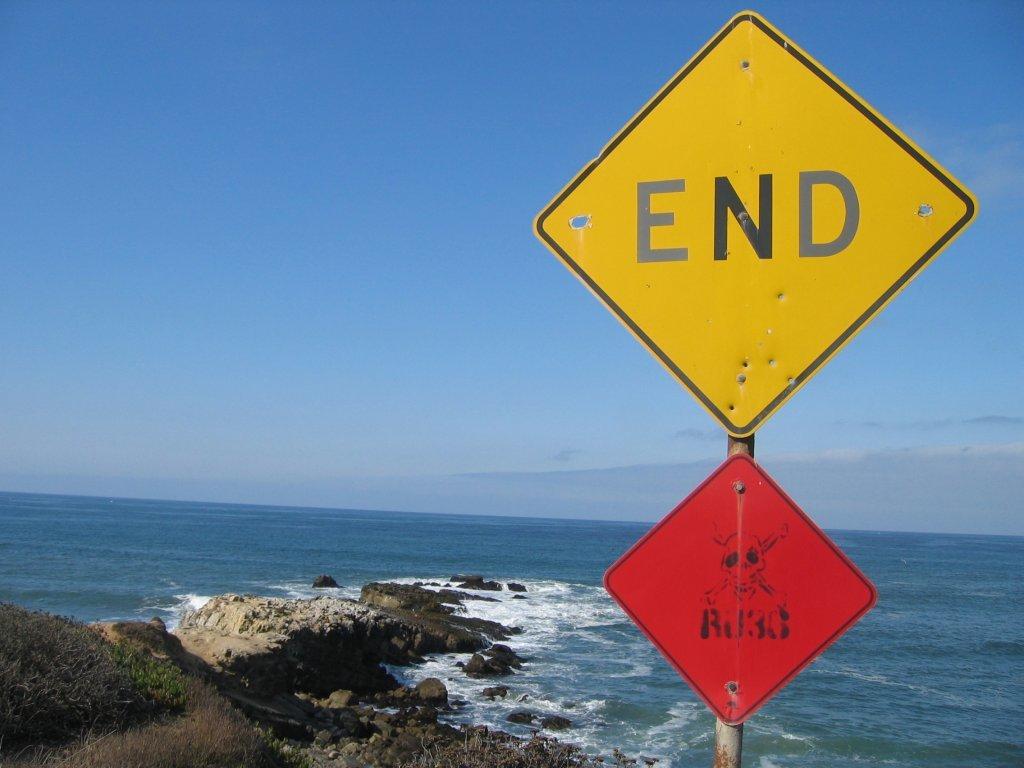What does the large yellow sign say?
Keep it short and to the point. End. 